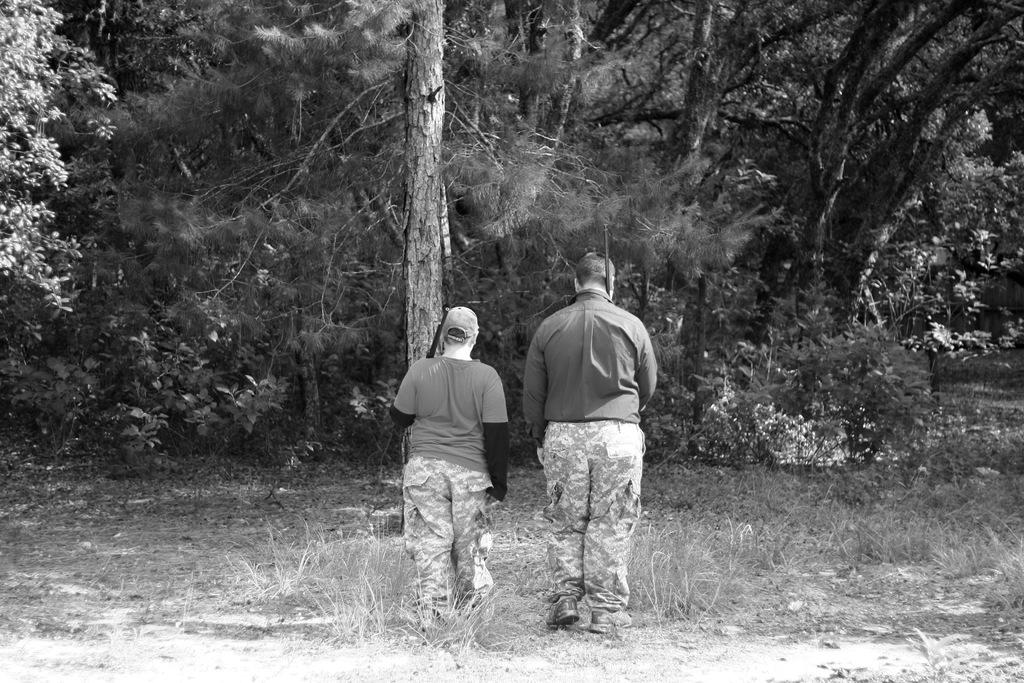What is the color scheme of the image? The image is black and white. How many people are in the image? There are two people in the image. What are the people doing in the image? The people are holding objects and walking on the grass. What is in front of the people in the image? There are trees and plants in front of the people. What type of floor can be seen under the people in the image? The image is black and white, and there is no indication of a floor; the people are walking on grass. What kind of oatmeal is being served in the image? There is no oatmeal present in the image. 